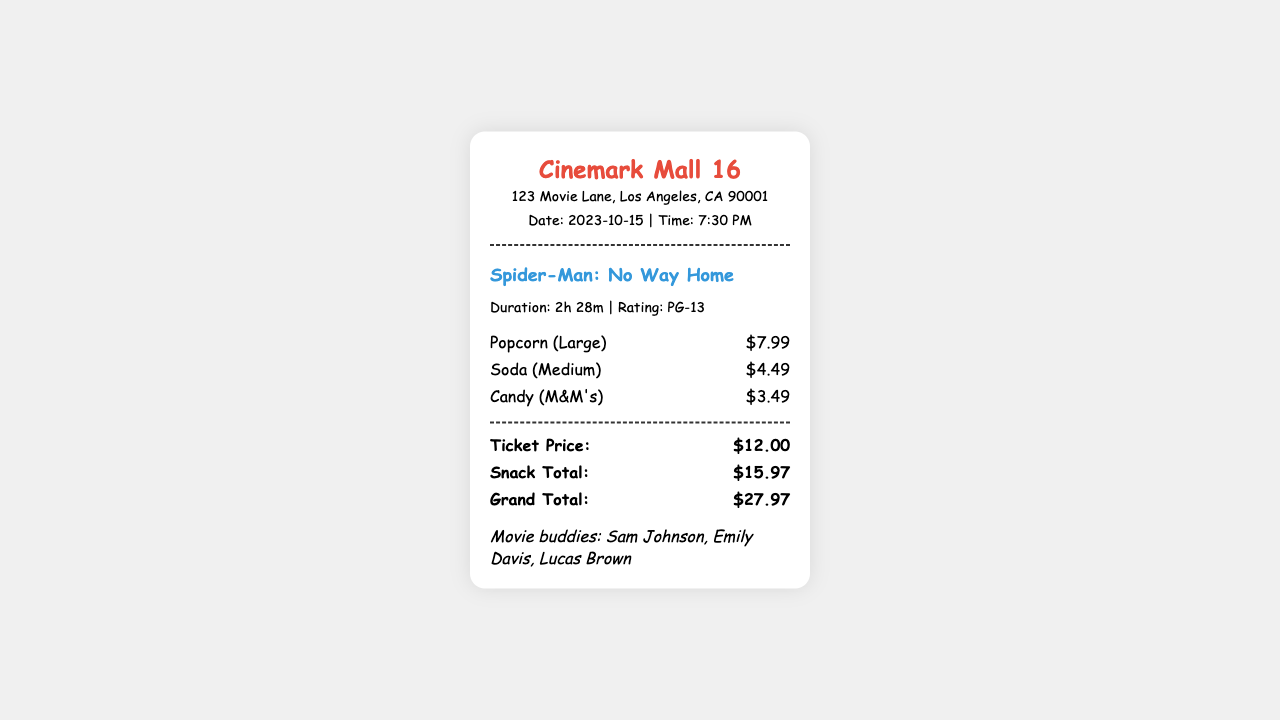What is the theater name? The theater name is prominently displayed at the top of the receipt under "Cinemark Mall 16."
Answer: Cinemark Mall 16 What is the date of the movie? The date is mentioned in the details section of the receipt, which is essential for confirming when the event occurred.
Answer: 2023-10-15 What snacks were purchased? The snacks section lists all items bought, showing what was included in the outing.
Answer: Popcorn (Large), Soda (Medium), Candy (M&M's) What is the ticket price? The ticket price is provided in the total section, outlining the cost for entry to the movie.
Answer: $12.00 Who are the movie buddies? The friends' names are listed at the bottom of the receipt, indicating who attended the movie together.
Answer: Sam Johnson, Emily Davis, Lucas Brown What is the total cost? The grand total is the sum total displayed at the end, which accounts for both the ticket and snacks.
Answer: $27.97 What is the duration of the movie? The duration is stated in the details section and is an important aspect of what to expect from the film.
Answer: 2h 28m What is the rating of the movie? The rating is mentioned in the details section, indicating the suitability of the film for viewers.
Answer: PG-13 What is the snack total? The snack total is shown in the total section and reflects the expenditure for all snacks purchased.
Answer: $15.97 